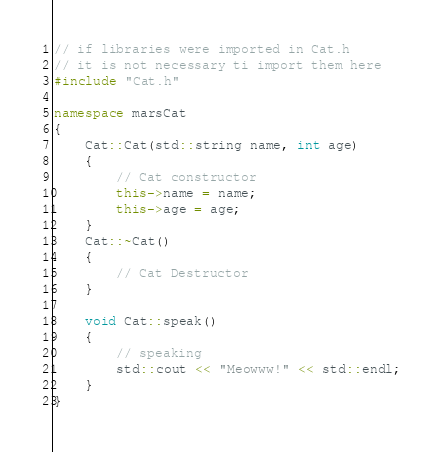<code> <loc_0><loc_0><loc_500><loc_500><_C++_>// if libraries were imported in Cat.h
// it is not necessary ti import them here
#include "Cat.h"

namespace marsCat
{
    Cat::Cat(std::string name, int age)
    {
        // Cat constructor
        this->name = name;
        this->age = age;
    }
    Cat::~Cat()
    {
        // Cat Destructor
    }

    void Cat::speak()
    {
        // speaking
        std::cout << "Meowww!" << std::endl;
    }
}</code> 